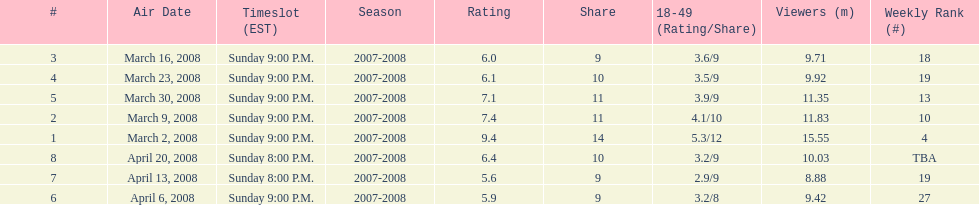How many shows had at least 10 million viewers? 4. 